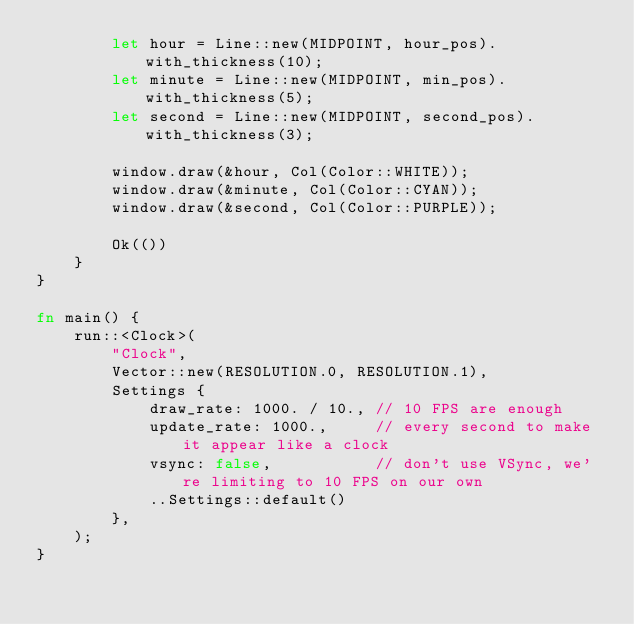<code> <loc_0><loc_0><loc_500><loc_500><_Rust_>        let hour = Line::new(MIDPOINT, hour_pos).with_thickness(10);
        let minute = Line::new(MIDPOINT, min_pos).with_thickness(5);
        let second = Line::new(MIDPOINT, second_pos).with_thickness(3);

        window.draw(&hour, Col(Color::WHITE));
        window.draw(&minute, Col(Color::CYAN));
        window.draw(&second, Col(Color::PURPLE));

        Ok(())
    }
}

fn main() {
    run::<Clock>(
        "Clock",
        Vector::new(RESOLUTION.0, RESOLUTION.1),
        Settings {
            draw_rate: 1000. / 10., // 10 FPS are enough
            update_rate: 1000.,     // every second to make it appear like a clock
            vsync: false,           // don't use VSync, we're limiting to 10 FPS on our own
            ..Settings::default()
        },
    );
}
</code> 